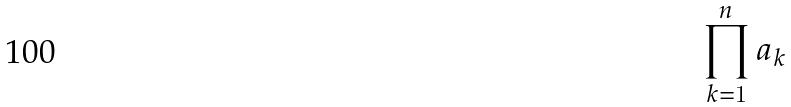Convert formula to latex. <formula><loc_0><loc_0><loc_500><loc_500>\prod _ { k = 1 } ^ { n } a _ { k }</formula> 